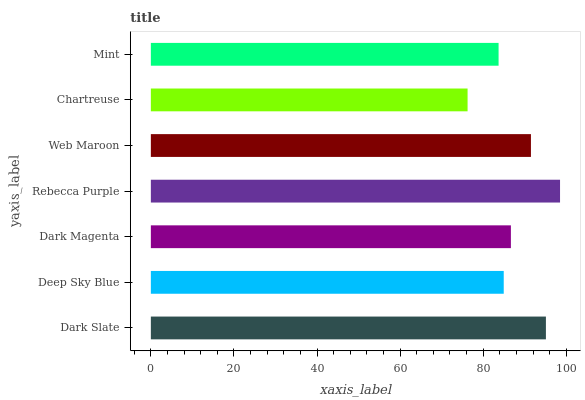Is Chartreuse the minimum?
Answer yes or no. Yes. Is Rebecca Purple the maximum?
Answer yes or no. Yes. Is Deep Sky Blue the minimum?
Answer yes or no. No. Is Deep Sky Blue the maximum?
Answer yes or no. No. Is Dark Slate greater than Deep Sky Blue?
Answer yes or no. Yes. Is Deep Sky Blue less than Dark Slate?
Answer yes or no. Yes. Is Deep Sky Blue greater than Dark Slate?
Answer yes or no. No. Is Dark Slate less than Deep Sky Blue?
Answer yes or no. No. Is Dark Magenta the high median?
Answer yes or no. Yes. Is Dark Magenta the low median?
Answer yes or no. Yes. Is Mint the high median?
Answer yes or no. No. Is Web Maroon the low median?
Answer yes or no. No. 